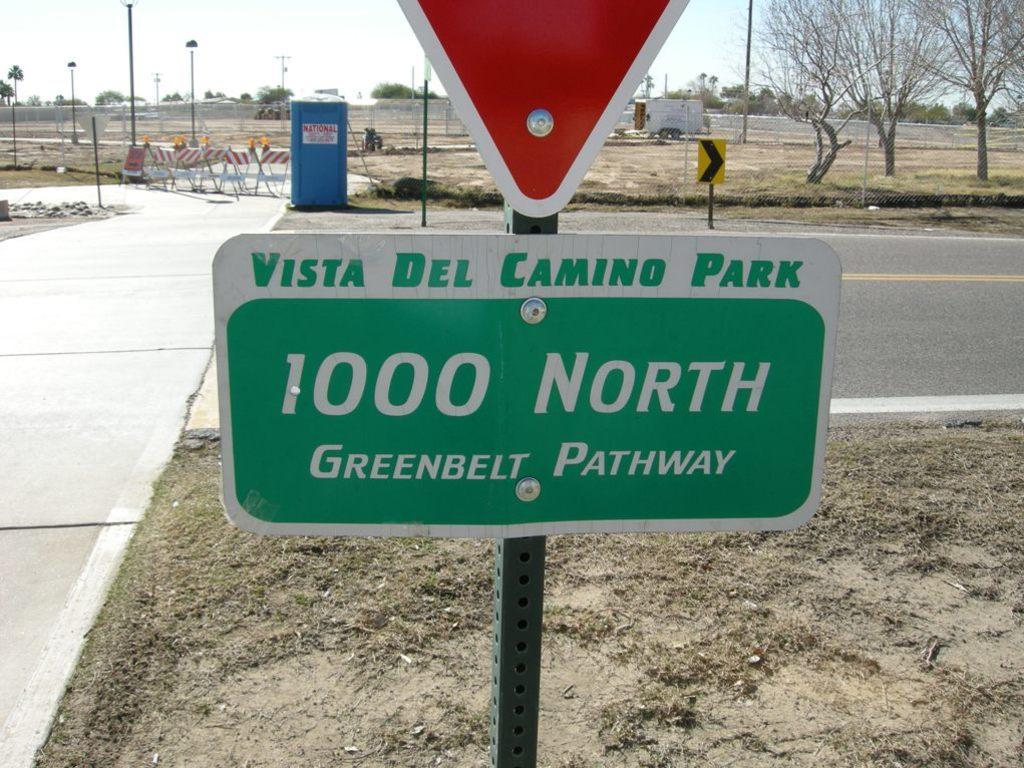Provide a one-sentence caption for the provided image. Sign that says Vista Del Camino Park 1000 North Greenbelt Pathway. 